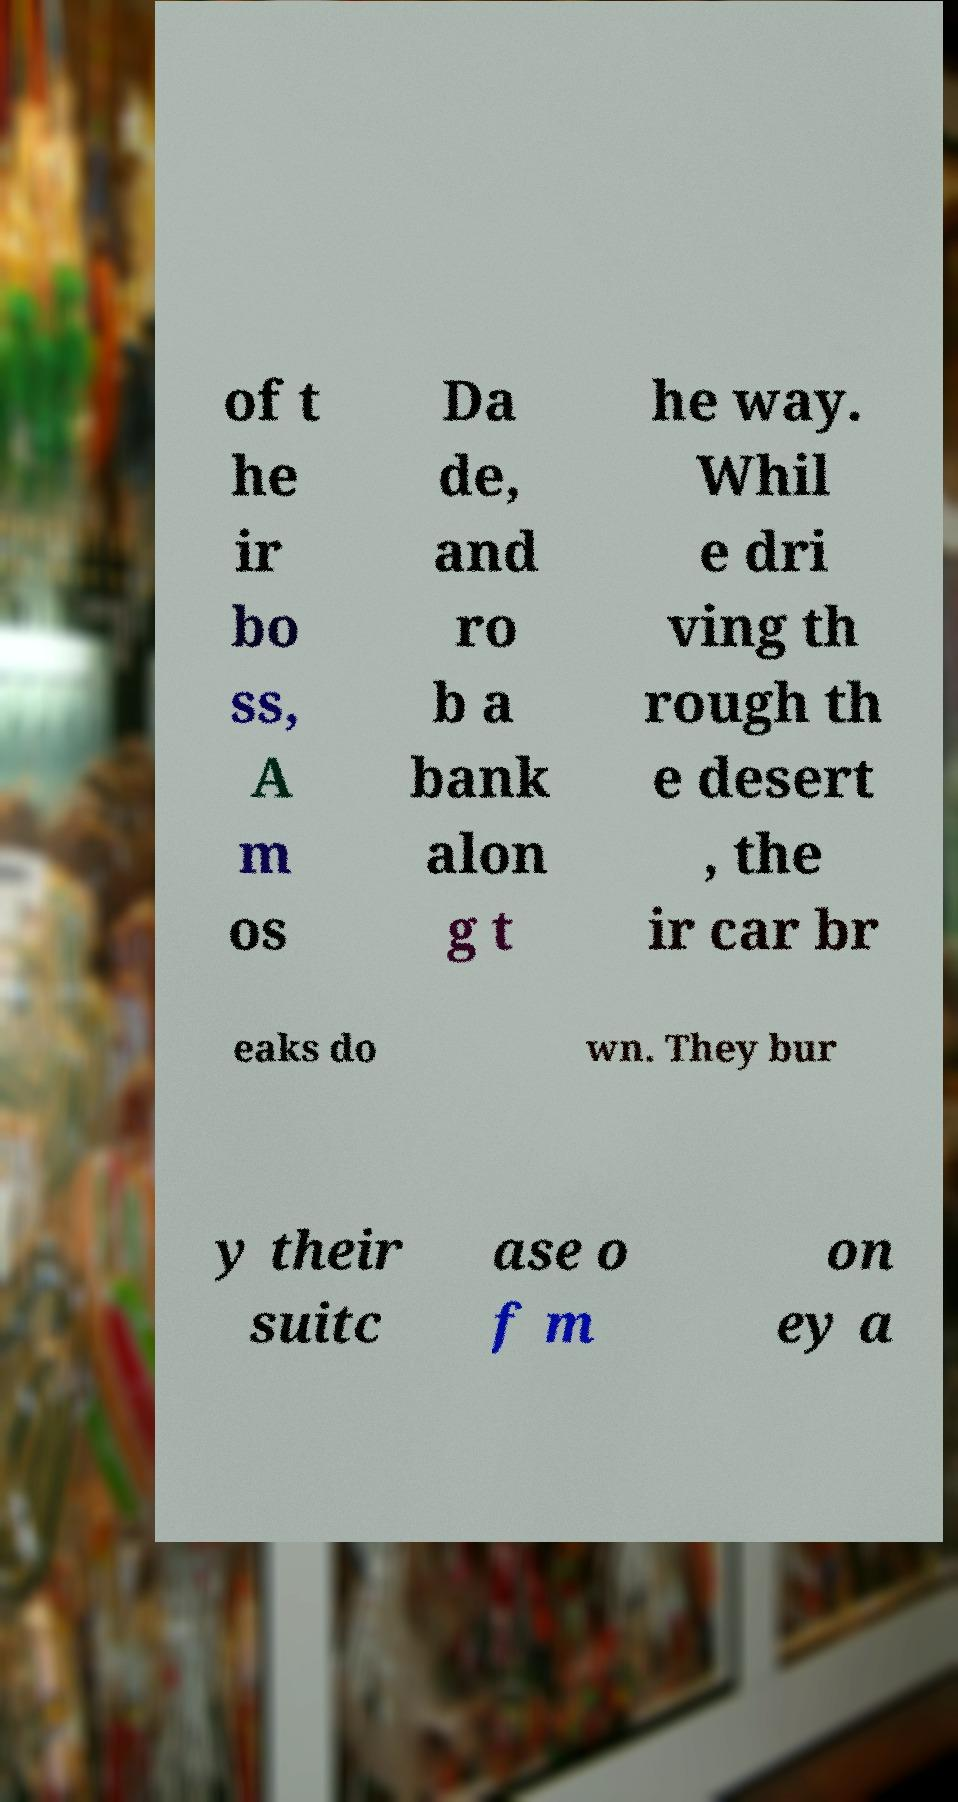Could you assist in decoding the text presented in this image and type it out clearly? of t he ir bo ss, A m os Da de, and ro b a bank alon g t he way. Whil e dri ving th rough th e desert , the ir car br eaks do wn. They bur y their suitc ase o f m on ey a 